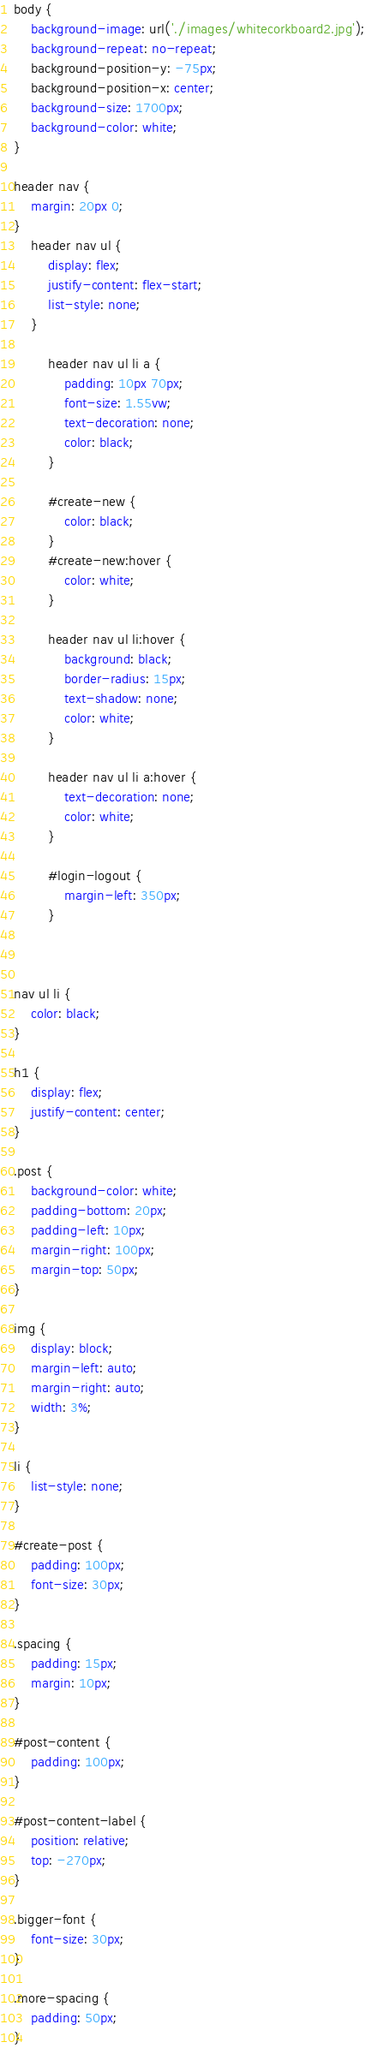<code> <loc_0><loc_0><loc_500><loc_500><_CSS_>body {
    background-image: url('./images/whitecorkboard2.jpg');
    background-repeat: no-repeat;
    background-position-y: -75px;
    background-position-x: center;
    background-size: 1700px;
    background-color: white;
}

header nav {
    margin: 20px 0;
}
    header nav ul {
        display: flex;
        justify-content: flex-start;
        list-style: none;
    }

        header nav ul li a {
            padding: 10px 70px;
            font-size: 1.55vw;
            text-decoration: none;
            color: black;
        }

        #create-new {
            color: black;
        }
        #create-new:hover {
            color: white;
        }

        header nav ul li:hover {
            background: black;
            border-radius: 15px;
            text-shadow: none;
            color: white;
        }

        header nav ul li a:hover {
            text-decoration: none;
            color: white;
        }

        #login-logout {
            margin-left: 350px;
        }

        

nav ul li {
    color: black;
}  

h1 {
    display: flex;
    justify-content: center;
}

.post {
    background-color: white;
    padding-bottom: 20px;
    padding-left: 10px;
    margin-right: 100px;
    margin-top: 50px;
}

img {
    display: block;
    margin-left: auto;
    margin-right: auto;
    width: 3%;
}

li {
    list-style: none;
}

#create-post {
    padding: 100px;
    font-size: 30px;
}

.spacing {
    padding: 15px;
    margin: 10px;
}

#post-content {
    padding: 100px;
}

#post-content-label {
    position: relative;
    top: -270px;
}

.bigger-font {
    font-size: 30px;
}

.more-spacing {
    padding: 50px;
}</code> 